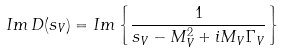Convert formula to latex. <formula><loc_0><loc_0><loc_500><loc_500>I m \, D ( s _ { V } ) = I m \left \{ \frac { 1 } { s _ { V } - M ^ { 2 } _ { V } + i M _ { V } \Gamma _ { V } } \right \}</formula> 